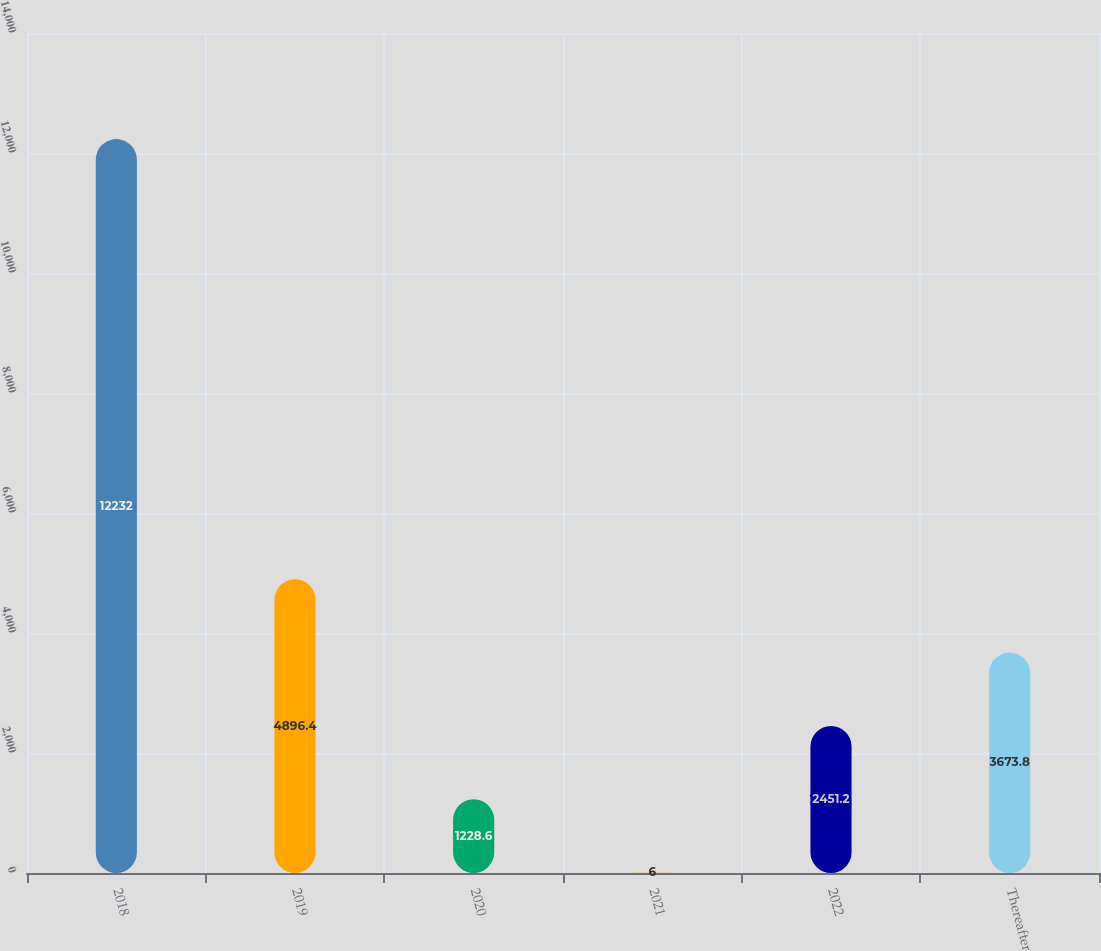Convert chart to OTSL. <chart><loc_0><loc_0><loc_500><loc_500><bar_chart><fcel>2018<fcel>2019<fcel>2020<fcel>2021<fcel>2022<fcel>Thereafter<nl><fcel>12232<fcel>4896.4<fcel>1228.6<fcel>6<fcel>2451.2<fcel>3673.8<nl></chart> 